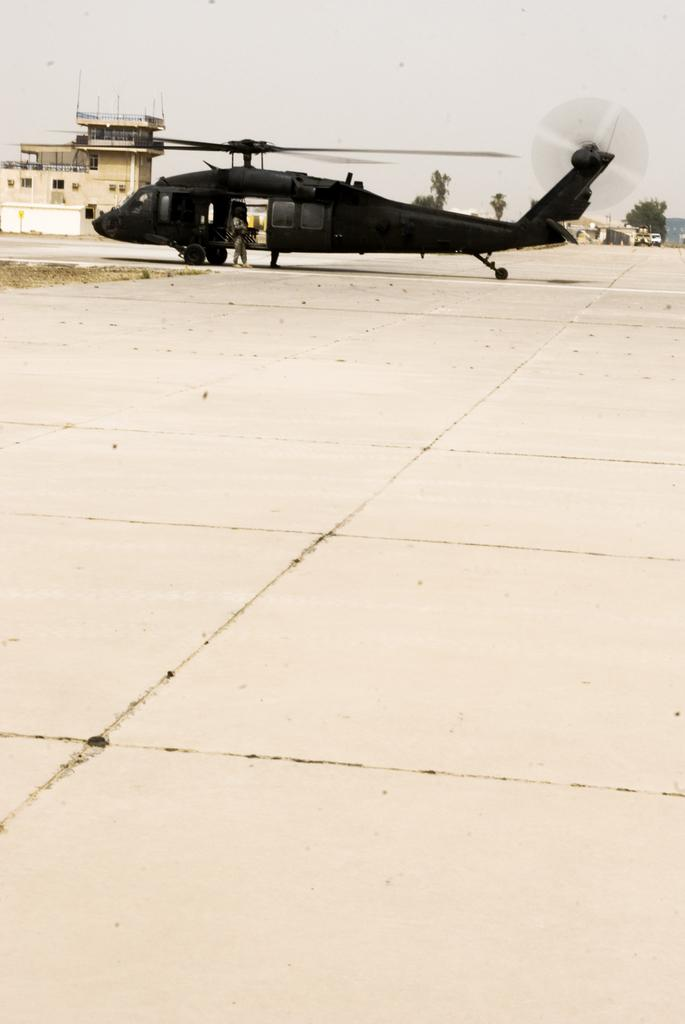What is the main subject of the image? The main subject of the image is a helicopter on the ground. What can be seen in the background of the image? There is a building and trees in the background of the image. What is visible above the trees and building? The sky is visible in the background of the image. What type of feast is being prepared in the helicopter? There is no indication of a feast or any food preparation in the image; it features a helicopter on the ground with a background of a building, trees, and sky. 